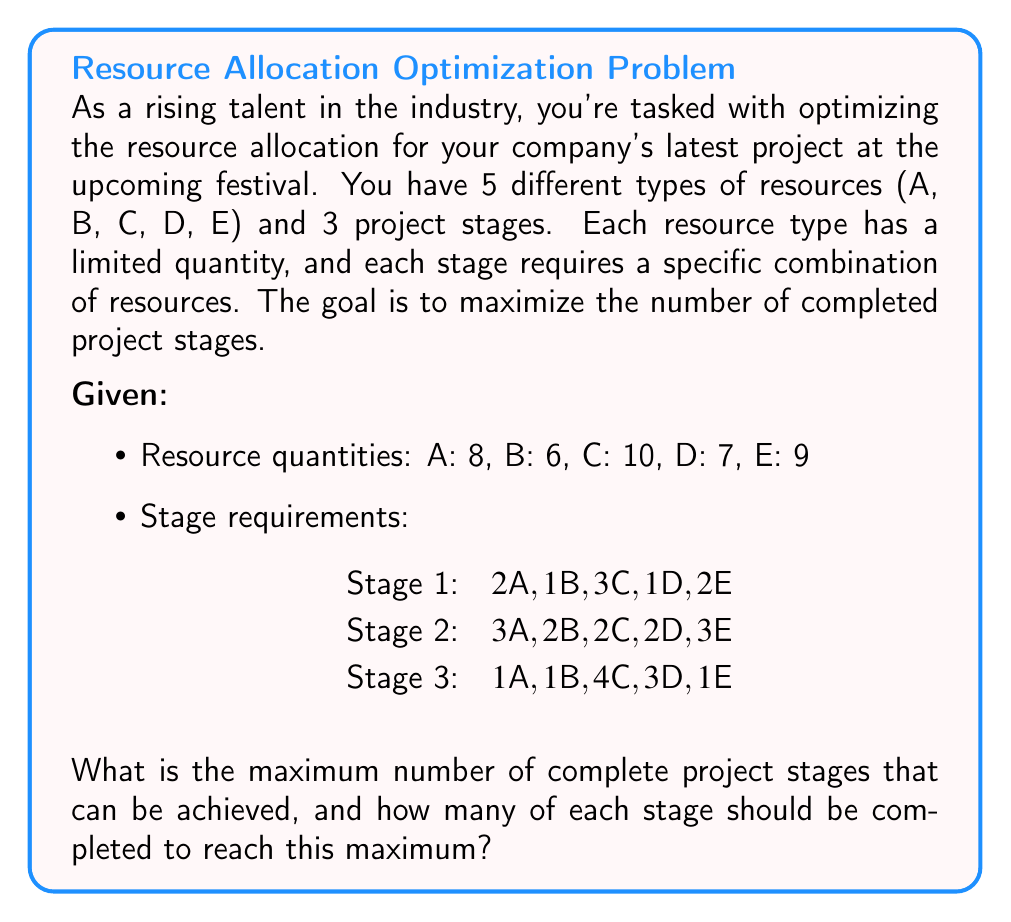Show me your answer to this math problem. To solve this combinatorial optimization problem, we'll use a greedy approach combined with linear programming concepts:

1. Calculate the maximum number of each stage that can be completed independently:

   Stage 1: min(8/2, 6/1, 10/3, 7/1, 9/2) = min(4, 6, 3, 7, 4) = 3
   Stage 2: min(8/3, 6/2, 10/2, 7/2, 9/3) = min(2, 3, 5, 3, 3) = 2
   Stage 3: min(8/1, 6/1, 10/4, 7/3, 9/1) = min(8, 6, 2, 2, 9) = 2

2. Start with the stage that has the lowest maximum (Stage 2 and 3 tie at 2):
   Choose Stage 2 as it uses more resources overall.

3. Allocate resources for 2 units of Stage 2:
   Resources left: A: 2, B: 2, C: 6, D: 3, E: 3

4. With remaining resources, calculate max for Stage 1 and 3:
   Stage 1: min(2/2, 2/1, 6/3, 3/1, 3/2) = min(1, 2, 2, 3, 1) = 1
   Stage 3: min(2/1, 2/1, 6/4, 3/3, 3/1) = min(2, 2, 1, 1, 3) = 1

5. Choose Stage 1 as it uses more resources overall.

6. Allocate resources for 1 unit of Stage 1:
   Resources left: A: 0, B: 1, C: 3, D: 2, E: 1

7. Remaining resources are insufficient for any more complete stages.

Therefore, the maximum number of complete project stages is 3, with 2 units of Stage 2 and 1 unit of Stage 1.
Answer: Maximum number of complete project stages: 3
Stage distribution: 1 of Stage 1, 2 of Stage 2, 0 of Stage 3 